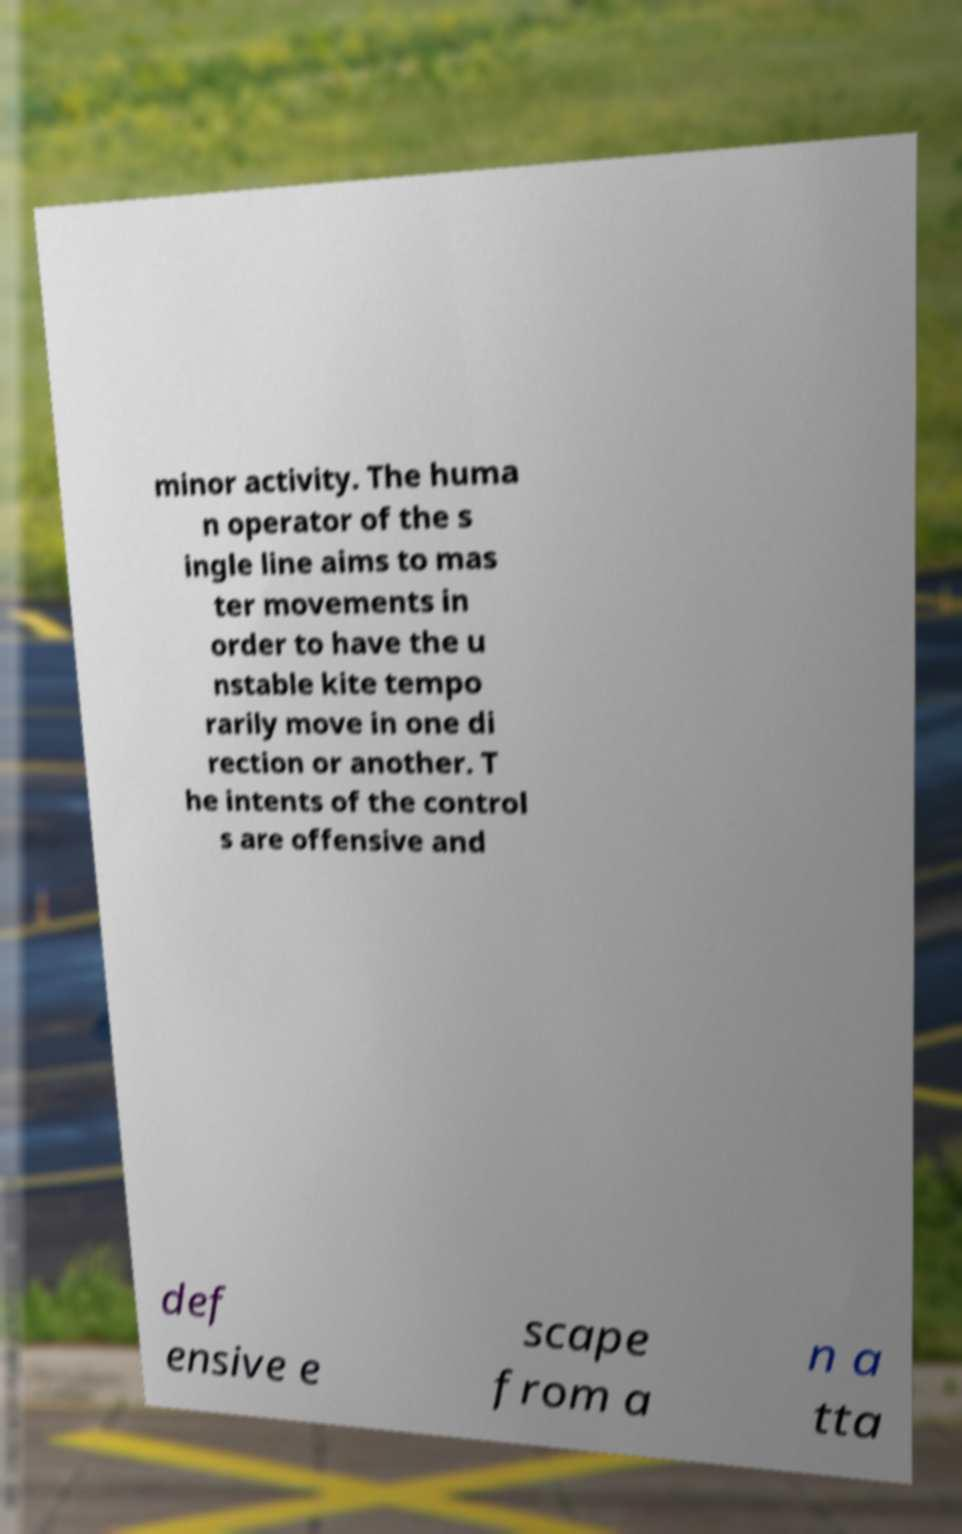I need the written content from this picture converted into text. Can you do that? minor activity. The huma n operator of the s ingle line aims to mas ter movements in order to have the u nstable kite tempo rarily move in one di rection or another. T he intents of the control s are offensive and def ensive e scape from a n a tta 